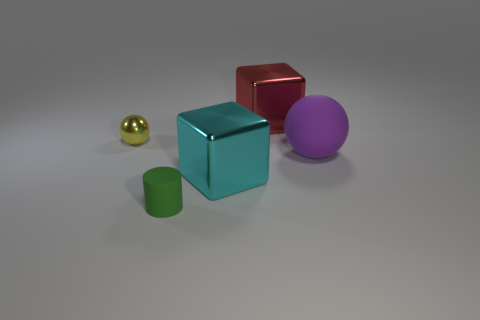Add 1 small matte things. How many objects exist? 6 Subtract all balls. How many objects are left? 3 Subtract all green cylinders. Subtract all tiny matte cylinders. How many objects are left? 3 Add 2 metal blocks. How many metal blocks are left? 4 Add 1 large objects. How many large objects exist? 4 Subtract 0 yellow cylinders. How many objects are left? 5 